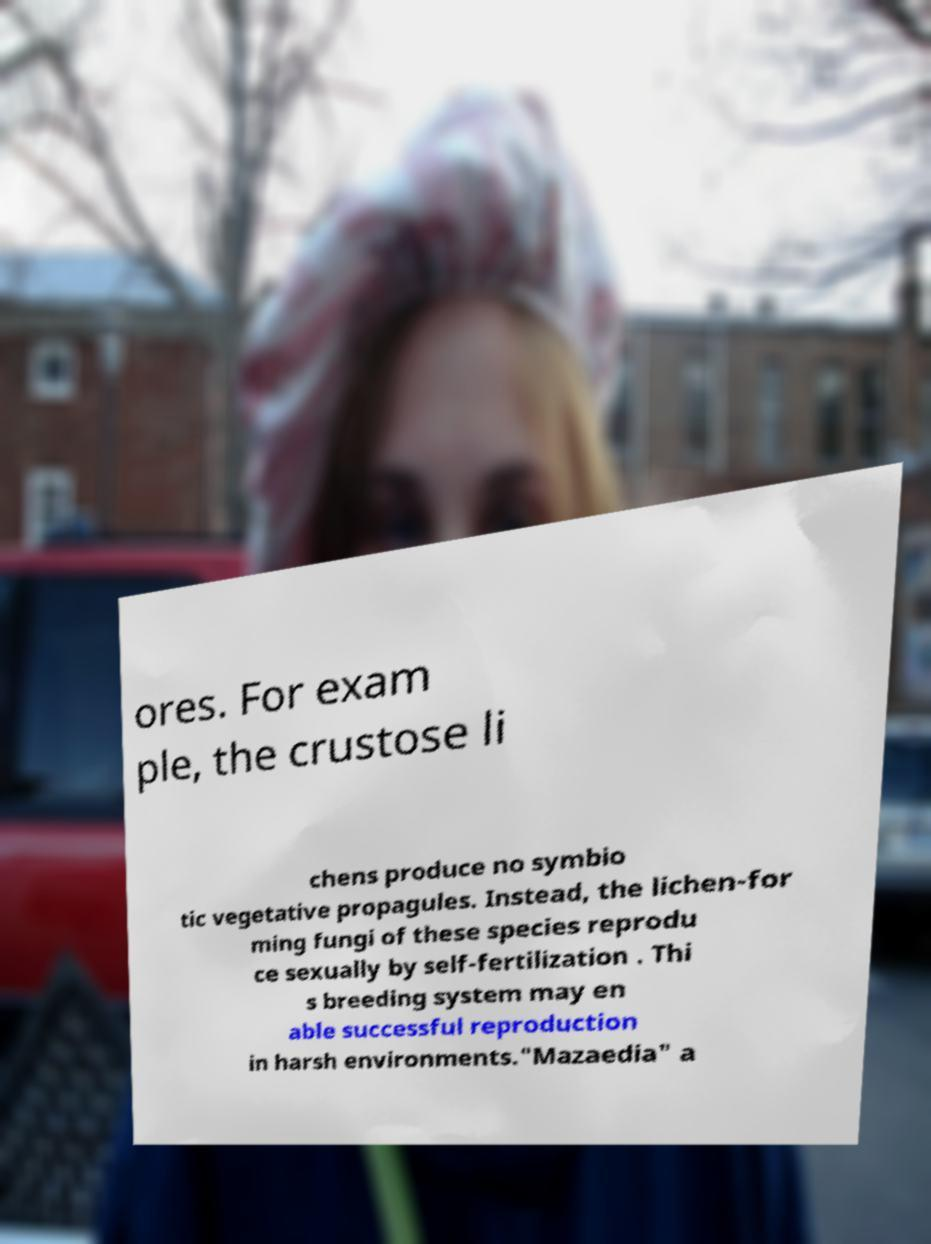Could you extract and type out the text from this image? ores. For exam ple, the crustose li chens produce no symbio tic vegetative propagules. Instead, the lichen-for ming fungi of these species reprodu ce sexually by self-fertilization . Thi s breeding system may en able successful reproduction in harsh environments."Mazaedia" a 